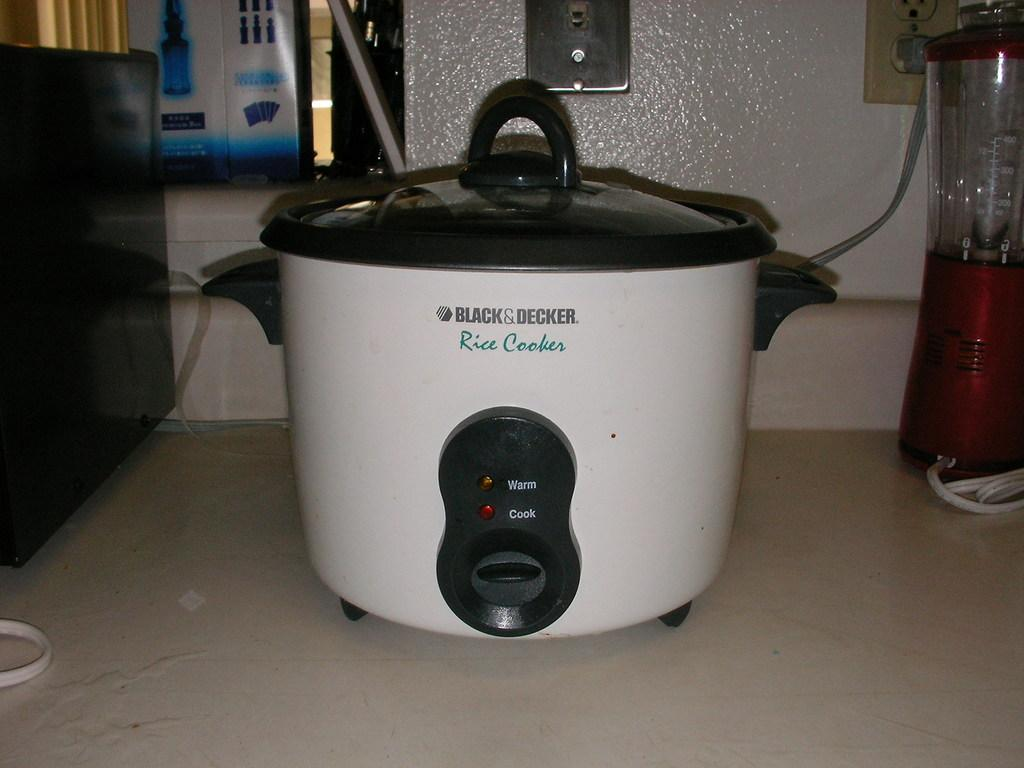Provide a one-sentence caption for the provided image. A black and decker rice cooker sitting on a counter. 